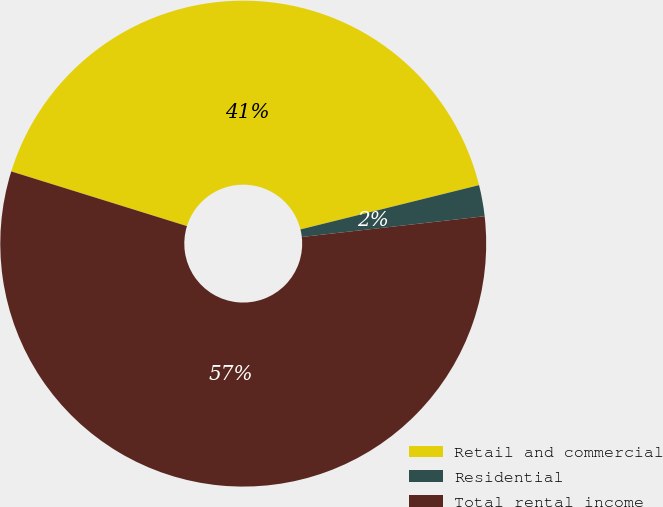Convert chart. <chart><loc_0><loc_0><loc_500><loc_500><pie_chart><fcel>Retail and commercial<fcel>Residential<fcel>Total rental income<nl><fcel>41.33%<fcel>2.07%<fcel>56.6%<nl></chart> 